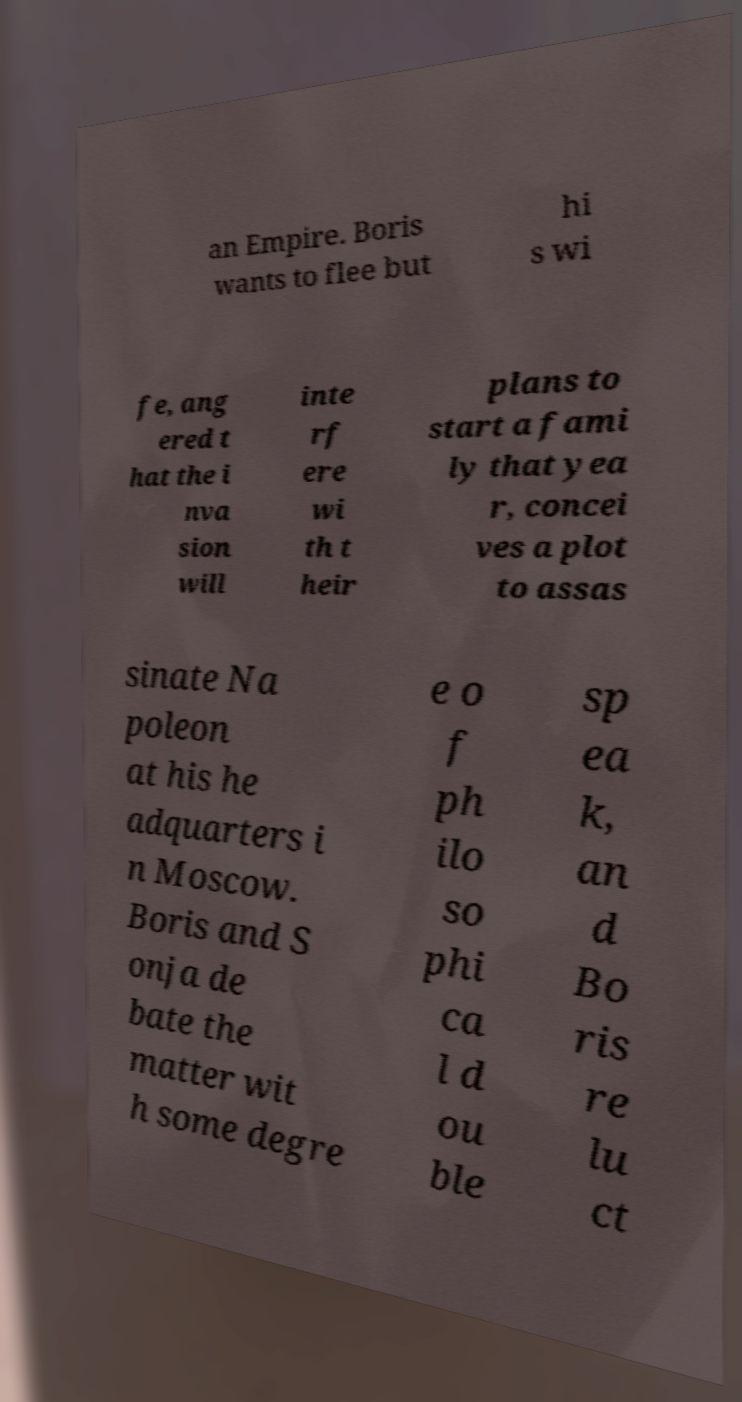Please identify and transcribe the text found in this image. an Empire. Boris wants to flee but hi s wi fe, ang ered t hat the i nva sion will inte rf ere wi th t heir plans to start a fami ly that yea r, concei ves a plot to assas sinate Na poleon at his he adquarters i n Moscow. Boris and S onja de bate the matter wit h some degre e o f ph ilo so phi ca l d ou ble sp ea k, an d Bo ris re lu ct 